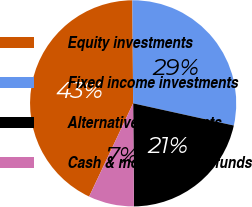Convert chart. <chart><loc_0><loc_0><loc_500><loc_500><pie_chart><fcel>Equity investments<fcel>Fixed income investments<fcel>Alternative investments<fcel>Cash & money market funds<nl><fcel>42.86%<fcel>28.57%<fcel>21.43%<fcel>7.14%<nl></chart> 